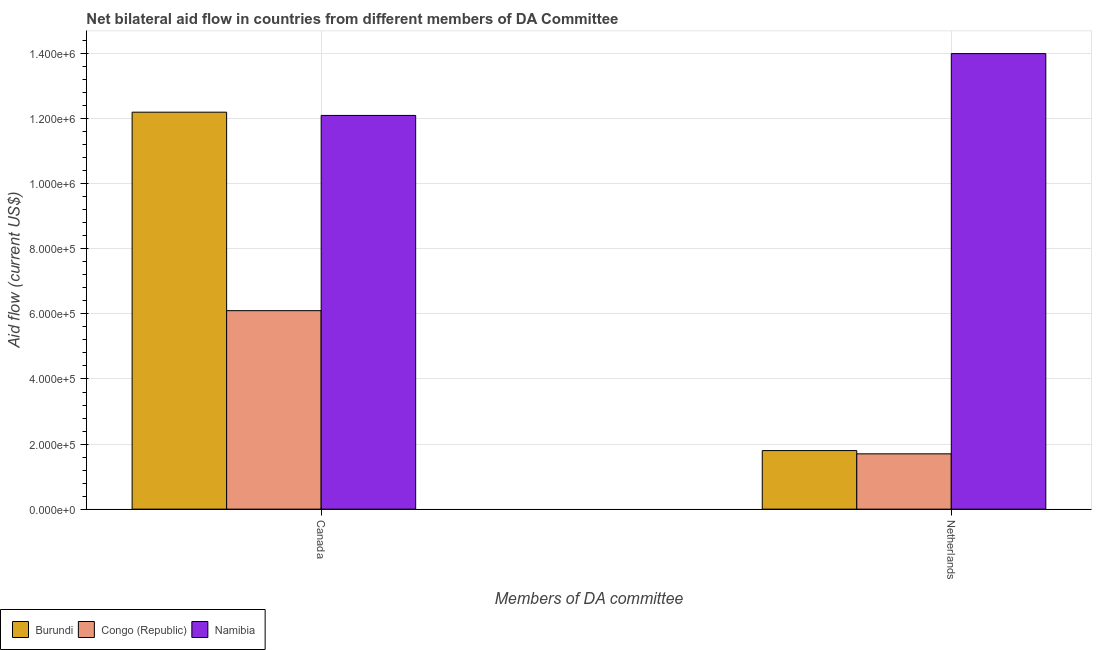How many groups of bars are there?
Give a very brief answer. 2. Are the number of bars per tick equal to the number of legend labels?
Provide a short and direct response. Yes. What is the amount of aid given by canada in Congo (Republic)?
Provide a succinct answer. 6.10e+05. Across all countries, what is the maximum amount of aid given by canada?
Ensure brevity in your answer.  1.22e+06. Across all countries, what is the minimum amount of aid given by canada?
Offer a terse response. 6.10e+05. In which country was the amount of aid given by netherlands maximum?
Your answer should be very brief. Namibia. In which country was the amount of aid given by canada minimum?
Provide a succinct answer. Congo (Republic). What is the total amount of aid given by canada in the graph?
Keep it short and to the point. 3.04e+06. What is the difference between the amount of aid given by canada in Burundi and that in Congo (Republic)?
Offer a very short reply. 6.10e+05. What is the difference between the amount of aid given by canada in Congo (Republic) and the amount of aid given by netherlands in Namibia?
Keep it short and to the point. -7.90e+05. What is the average amount of aid given by canada per country?
Your response must be concise. 1.01e+06. What is the difference between the amount of aid given by canada and amount of aid given by netherlands in Namibia?
Keep it short and to the point. -1.90e+05. What is the ratio of the amount of aid given by canada in Burundi to that in Namibia?
Provide a succinct answer. 1.01. In how many countries, is the amount of aid given by canada greater than the average amount of aid given by canada taken over all countries?
Provide a succinct answer. 2. What does the 2nd bar from the left in Canada represents?
Provide a succinct answer. Congo (Republic). What does the 1st bar from the right in Canada represents?
Keep it short and to the point. Namibia. How many bars are there?
Ensure brevity in your answer.  6. Are the values on the major ticks of Y-axis written in scientific E-notation?
Make the answer very short. Yes. Does the graph contain any zero values?
Make the answer very short. No. Does the graph contain grids?
Your response must be concise. Yes. How are the legend labels stacked?
Provide a succinct answer. Horizontal. What is the title of the graph?
Your response must be concise. Net bilateral aid flow in countries from different members of DA Committee. What is the label or title of the X-axis?
Provide a short and direct response. Members of DA committee. What is the label or title of the Y-axis?
Offer a very short reply. Aid flow (current US$). What is the Aid flow (current US$) in Burundi in Canada?
Provide a short and direct response. 1.22e+06. What is the Aid flow (current US$) in Congo (Republic) in Canada?
Your answer should be very brief. 6.10e+05. What is the Aid flow (current US$) in Namibia in Canada?
Offer a very short reply. 1.21e+06. What is the Aid flow (current US$) in Burundi in Netherlands?
Your answer should be very brief. 1.80e+05. What is the Aid flow (current US$) in Namibia in Netherlands?
Your response must be concise. 1.40e+06. Across all Members of DA committee, what is the maximum Aid flow (current US$) of Burundi?
Keep it short and to the point. 1.22e+06. Across all Members of DA committee, what is the maximum Aid flow (current US$) in Namibia?
Give a very brief answer. 1.40e+06. Across all Members of DA committee, what is the minimum Aid flow (current US$) of Congo (Republic)?
Ensure brevity in your answer.  1.70e+05. Across all Members of DA committee, what is the minimum Aid flow (current US$) in Namibia?
Offer a very short reply. 1.21e+06. What is the total Aid flow (current US$) of Burundi in the graph?
Keep it short and to the point. 1.40e+06. What is the total Aid flow (current US$) of Congo (Republic) in the graph?
Offer a terse response. 7.80e+05. What is the total Aid flow (current US$) of Namibia in the graph?
Your answer should be very brief. 2.61e+06. What is the difference between the Aid flow (current US$) of Burundi in Canada and that in Netherlands?
Your response must be concise. 1.04e+06. What is the difference between the Aid flow (current US$) in Namibia in Canada and that in Netherlands?
Keep it short and to the point. -1.90e+05. What is the difference between the Aid flow (current US$) of Burundi in Canada and the Aid flow (current US$) of Congo (Republic) in Netherlands?
Your answer should be compact. 1.05e+06. What is the difference between the Aid flow (current US$) of Congo (Republic) in Canada and the Aid flow (current US$) of Namibia in Netherlands?
Keep it short and to the point. -7.90e+05. What is the average Aid flow (current US$) of Burundi per Members of DA committee?
Give a very brief answer. 7.00e+05. What is the average Aid flow (current US$) in Namibia per Members of DA committee?
Keep it short and to the point. 1.30e+06. What is the difference between the Aid flow (current US$) of Burundi and Aid flow (current US$) of Congo (Republic) in Canada?
Offer a very short reply. 6.10e+05. What is the difference between the Aid flow (current US$) of Burundi and Aid flow (current US$) of Namibia in Canada?
Offer a terse response. 10000. What is the difference between the Aid flow (current US$) in Congo (Republic) and Aid flow (current US$) in Namibia in Canada?
Provide a succinct answer. -6.00e+05. What is the difference between the Aid flow (current US$) in Burundi and Aid flow (current US$) in Namibia in Netherlands?
Ensure brevity in your answer.  -1.22e+06. What is the difference between the Aid flow (current US$) of Congo (Republic) and Aid flow (current US$) of Namibia in Netherlands?
Your answer should be very brief. -1.23e+06. What is the ratio of the Aid flow (current US$) in Burundi in Canada to that in Netherlands?
Offer a terse response. 6.78. What is the ratio of the Aid flow (current US$) of Congo (Republic) in Canada to that in Netherlands?
Ensure brevity in your answer.  3.59. What is the ratio of the Aid flow (current US$) of Namibia in Canada to that in Netherlands?
Give a very brief answer. 0.86. What is the difference between the highest and the second highest Aid flow (current US$) of Burundi?
Offer a very short reply. 1.04e+06. What is the difference between the highest and the second highest Aid flow (current US$) in Congo (Republic)?
Offer a terse response. 4.40e+05. What is the difference between the highest and the second highest Aid flow (current US$) of Namibia?
Keep it short and to the point. 1.90e+05. What is the difference between the highest and the lowest Aid flow (current US$) in Burundi?
Offer a terse response. 1.04e+06. What is the difference between the highest and the lowest Aid flow (current US$) of Congo (Republic)?
Your response must be concise. 4.40e+05. What is the difference between the highest and the lowest Aid flow (current US$) in Namibia?
Make the answer very short. 1.90e+05. 